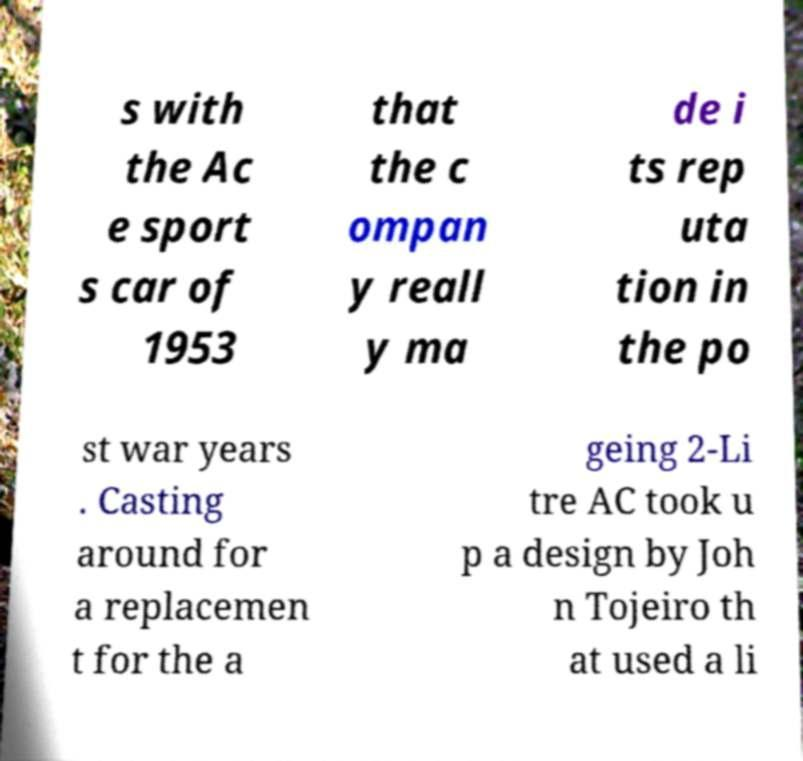Can you read and provide the text displayed in the image?This photo seems to have some interesting text. Can you extract and type it out for me? s with the Ac e sport s car of 1953 that the c ompan y reall y ma de i ts rep uta tion in the po st war years . Casting around for a replacemen t for the a geing 2-Li tre AC took u p a design by Joh n Tojeiro th at used a li 